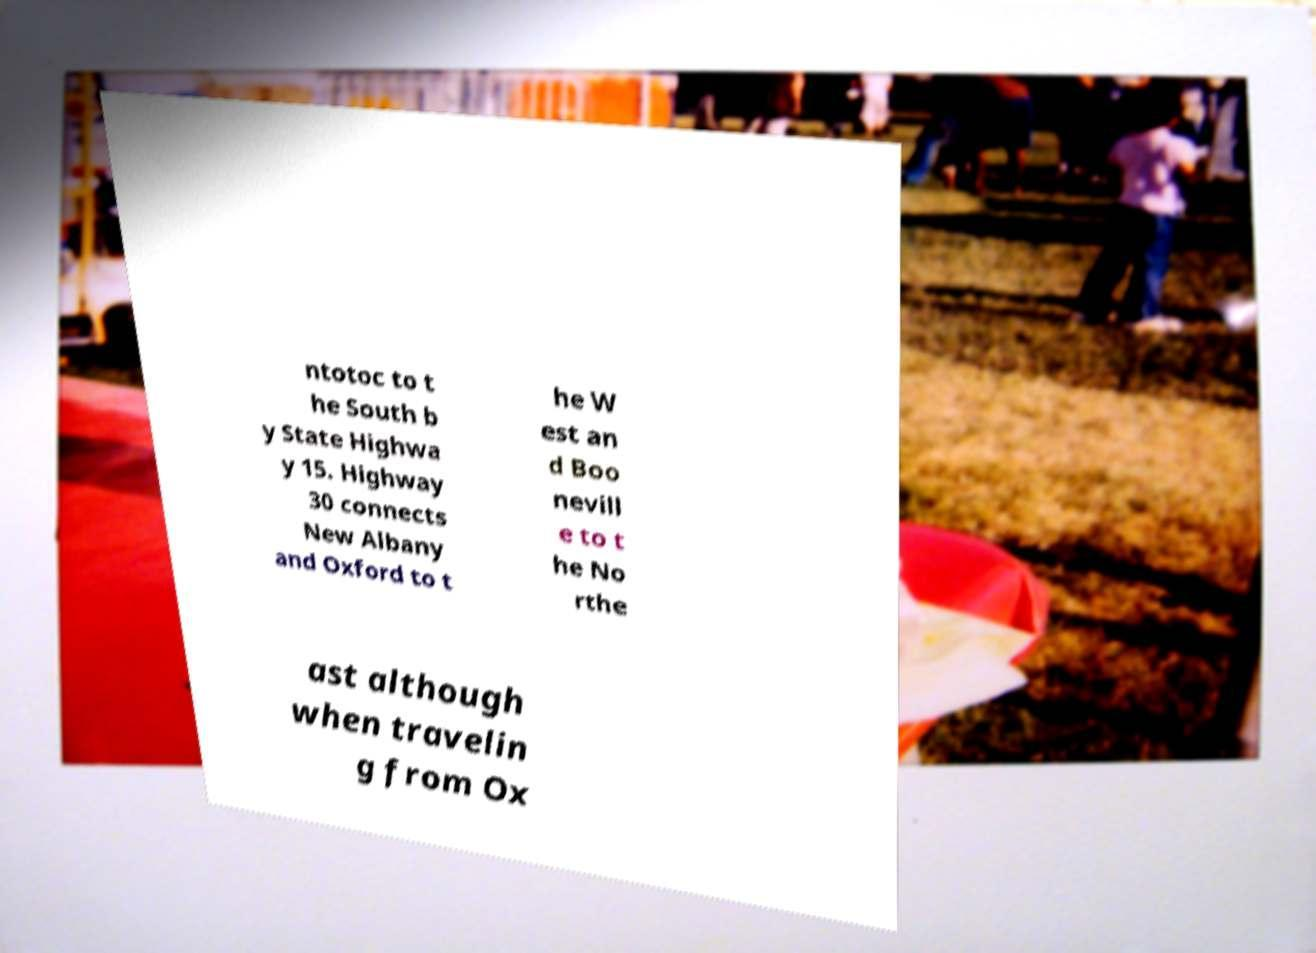Can you read and provide the text displayed in the image?This photo seems to have some interesting text. Can you extract and type it out for me? ntotoc to t he South b y State Highwa y 15. Highway 30 connects New Albany and Oxford to t he W est an d Boo nevill e to t he No rthe ast although when travelin g from Ox 